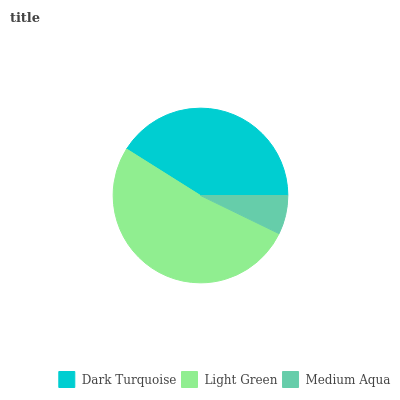Is Medium Aqua the minimum?
Answer yes or no. Yes. Is Light Green the maximum?
Answer yes or no. Yes. Is Light Green the minimum?
Answer yes or no. No. Is Medium Aqua the maximum?
Answer yes or no. No. Is Light Green greater than Medium Aqua?
Answer yes or no. Yes. Is Medium Aqua less than Light Green?
Answer yes or no. Yes. Is Medium Aqua greater than Light Green?
Answer yes or no. No. Is Light Green less than Medium Aqua?
Answer yes or no. No. Is Dark Turquoise the high median?
Answer yes or no. Yes. Is Dark Turquoise the low median?
Answer yes or no. Yes. Is Light Green the high median?
Answer yes or no. No. Is Light Green the low median?
Answer yes or no. No. 